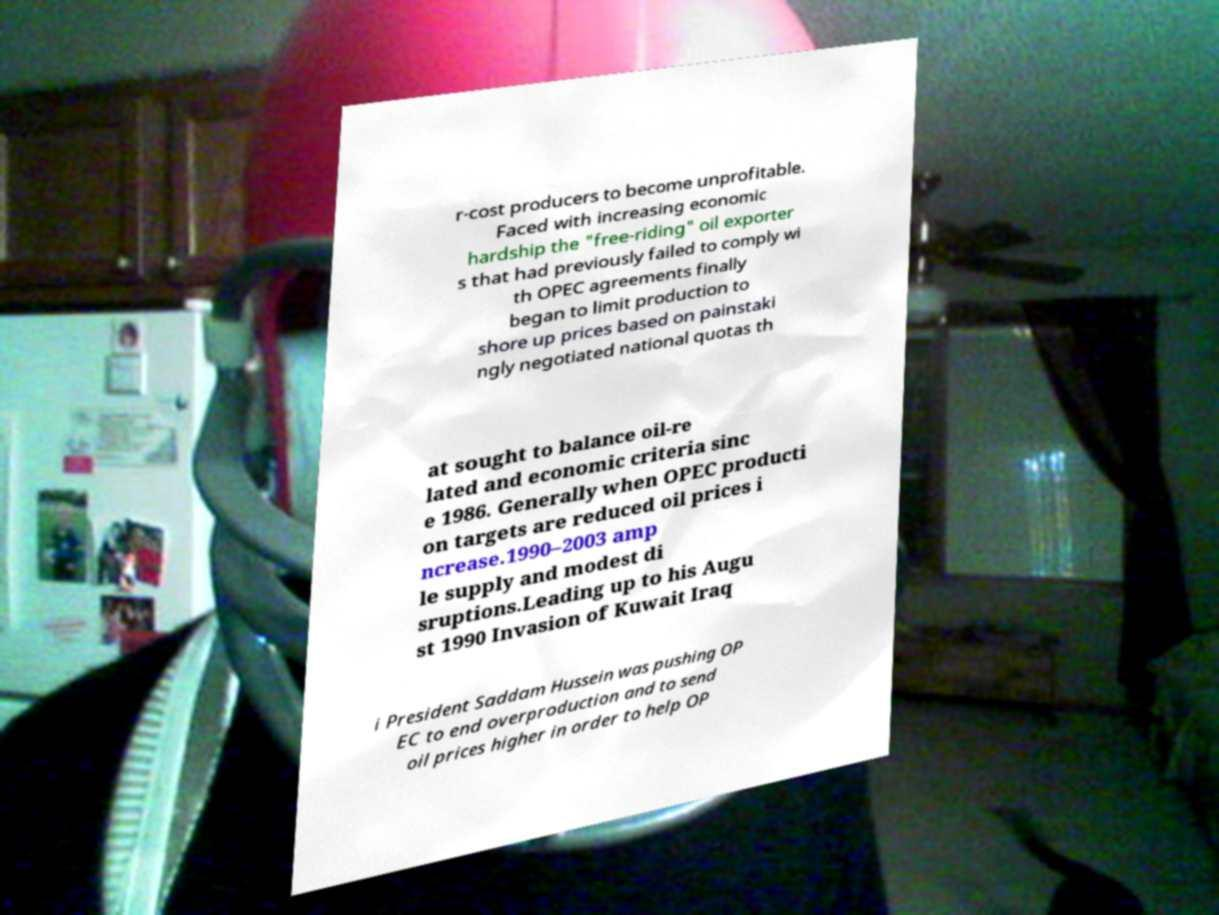Please identify and transcribe the text found in this image. r-cost producers to become unprofitable. Faced with increasing economic hardship the "free-riding" oil exporter s that had previously failed to comply wi th OPEC agreements finally began to limit production to shore up prices based on painstaki ngly negotiated national quotas th at sought to balance oil-re lated and economic criteria sinc e 1986. Generally when OPEC producti on targets are reduced oil prices i ncrease.1990–2003 amp le supply and modest di sruptions.Leading up to his Augu st 1990 Invasion of Kuwait Iraq i President Saddam Hussein was pushing OP EC to end overproduction and to send oil prices higher in order to help OP 